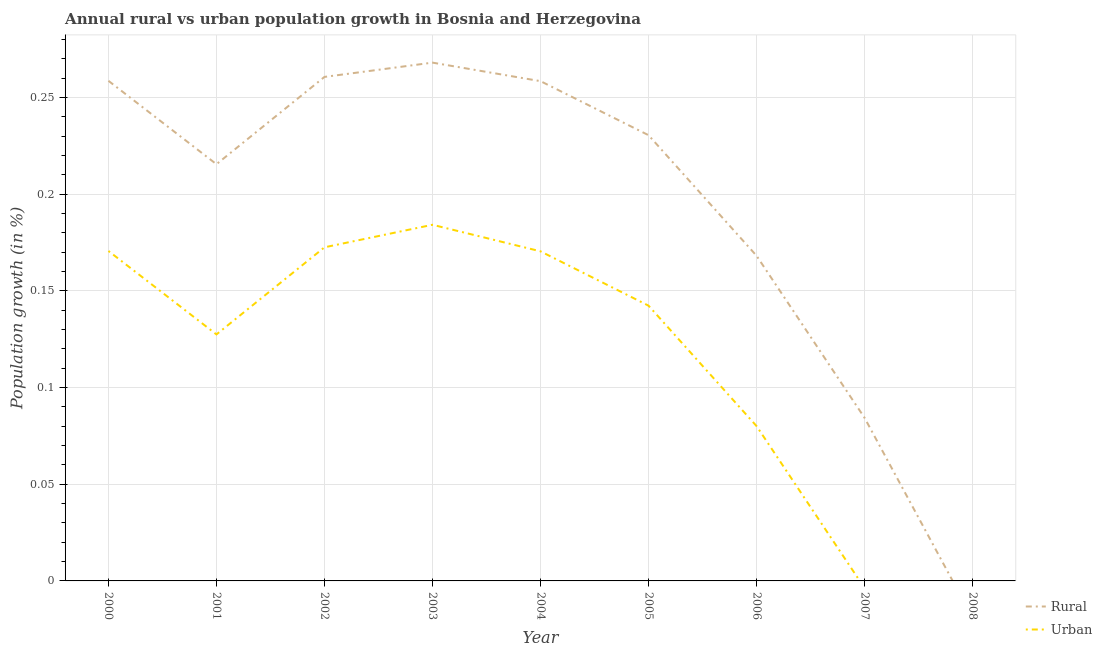How many different coloured lines are there?
Offer a very short reply. 2. Is the number of lines equal to the number of legend labels?
Give a very brief answer. No. What is the rural population growth in 2002?
Offer a very short reply. 0.26. Across all years, what is the maximum rural population growth?
Keep it short and to the point. 0.27. Across all years, what is the minimum urban population growth?
Give a very brief answer. 0. In which year was the urban population growth maximum?
Offer a terse response. 2003. What is the total rural population growth in the graph?
Offer a terse response. 1.74. What is the difference between the urban population growth in 2003 and that in 2006?
Give a very brief answer. 0.1. What is the difference between the rural population growth in 2006 and the urban population growth in 2002?
Your response must be concise. -0. What is the average rural population growth per year?
Give a very brief answer. 0.19. In the year 2004, what is the difference between the rural population growth and urban population growth?
Provide a succinct answer. 0.09. What is the ratio of the urban population growth in 2002 to that in 2003?
Keep it short and to the point. 0.94. Is the urban population growth in 2002 less than that in 2006?
Make the answer very short. No. What is the difference between the highest and the second highest rural population growth?
Offer a very short reply. 0.01. What is the difference between the highest and the lowest rural population growth?
Provide a succinct answer. 0.27. Is the rural population growth strictly greater than the urban population growth over the years?
Your answer should be very brief. No. Is the rural population growth strictly less than the urban population growth over the years?
Your response must be concise. No. Where does the legend appear in the graph?
Keep it short and to the point. Bottom right. What is the title of the graph?
Offer a very short reply. Annual rural vs urban population growth in Bosnia and Herzegovina. Does "Researchers" appear as one of the legend labels in the graph?
Keep it short and to the point. No. What is the label or title of the X-axis?
Provide a short and direct response. Year. What is the label or title of the Y-axis?
Offer a very short reply. Population growth (in %). What is the Population growth (in %) in Rural in 2000?
Your response must be concise. 0.26. What is the Population growth (in %) of Urban  in 2000?
Provide a succinct answer. 0.17. What is the Population growth (in %) in Rural in 2001?
Ensure brevity in your answer.  0.22. What is the Population growth (in %) in Urban  in 2001?
Ensure brevity in your answer.  0.13. What is the Population growth (in %) of Rural in 2002?
Make the answer very short. 0.26. What is the Population growth (in %) in Urban  in 2002?
Your answer should be very brief. 0.17. What is the Population growth (in %) of Rural in 2003?
Keep it short and to the point. 0.27. What is the Population growth (in %) of Urban  in 2003?
Keep it short and to the point. 0.18. What is the Population growth (in %) of Rural in 2004?
Provide a succinct answer. 0.26. What is the Population growth (in %) in Urban  in 2004?
Provide a short and direct response. 0.17. What is the Population growth (in %) of Rural in 2005?
Keep it short and to the point. 0.23. What is the Population growth (in %) of Urban  in 2005?
Give a very brief answer. 0.14. What is the Population growth (in %) of Rural in 2006?
Ensure brevity in your answer.  0.17. What is the Population growth (in %) of Urban  in 2006?
Ensure brevity in your answer.  0.08. What is the Population growth (in %) of Rural in 2007?
Make the answer very short. 0.08. What is the Population growth (in %) in Urban  in 2007?
Offer a terse response. 0. What is the Population growth (in %) in Rural in 2008?
Your answer should be compact. 0. What is the Population growth (in %) of Urban  in 2008?
Give a very brief answer. 0. Across all years, what is the maximum Population growth (in %) in Rural?
Your response must be concise. 0.27. Across all years, what is the maximum Population growth (in %) of Urban ?
Ensure brevity in your answer.  0.18. Across all years, what is the minimum Population growth (in %) in Rural?
Keep it short and to the point. 0. Across all years, what is the minimum Population growth (in %) in Urban ?
Your answer should be compact. 0. What is the total Population growth (in %) of Rural in the graph?
Your response must be concise. 1.74. What is the total Population growth (in %) in Urban  in the graph?
Provide a short and direct response. 1.05. What is the difference between the Population growth (in %) of Rural in 2000 and that in 2001?
Give a very brief answer. 0.04. What is the difference between the Population growth (in %) in Urban  in 2000 and that in 2001?
Offer a terse response. 0.04. What is the difference between the Population growth (in %) in Rural in 2000 and that in 2002?
Provide a short and direct response. -0. What is the difference between the Population growth (in %) in Urban  in 2000 and that in 2002?
Provide a short and direct response. -0. What is the difference between the Population growth (in %) in Rural in 2000 and that in 2003?
Offer a terse response. -0.01. What is the difference between the Population growth (in %) of Urban  in 2000 and that in 2003?
Provide a succinct answer. -0.01. What is the difference between the Population growth (in %) of Rural in 2000 and that in 2005?
Offer a very short reply. 0.03. What is the difference between the Population growth (in %) of Urban  in 2000 and that in 2005?
Your answer should be very brief. 0.03. What is the difference between the Population growth (in %) in Rural in 2000 and that in 2006?
Provide a short and direct response. 0.09. What is the difference between the Population growth (in %) of Urban  in 2000 and that in 2006?
Your response must be concise. 0.09. What is the difference between the Population growth (in %) of Rural in 2000 and that in 2007?
Offer a terse response. 0.17. What is the difference between the Population growth (in %) in Rural in 2001 and that in 2002?
Give a very brief answer. -0.05. What is the difference between the Population growth (in %) of Urban  in 2001 and that in 2002?
Your answer should be compact. -0.05. What is the difference between the Population growth (in %) of Rural in 2001 and that in 2003?
Provide a succinct answer. -0.05. What is the difference between the Population growth (in %) in Urban  in 2001 and that in 2003?
Make the answer very short. -0.06. What is the difference between the Population growth (in %) in Rural in 2001 and that in 2004?
Make the answer very short. -0.04. What is the difference between the Population growth (in %) in Urban  in 2001 and that in 2004?
Give a very brief answer. -0.04. What is the difference between the Population growth (in %) of Rural in 2001 and that in 2005?
Give a very brief answer. -0.01. What is the difference between the Population growth (in %) of Urban  in 2001 and that in 2005?
Make the answer very short. -0.01. What is the difference between the Population growth (in %) of Rural in 2001 and that in 2006?
Offer a terse response. 0.05. What is the difference between the Population growth (in %) in Urban  in 2001 and that in 2006?
Your answer should be compact. 0.05. What is the difference between the Population growth (in %) in Rural in 2001 and that in 2007?
Your answer should be very brief. 0.13. What is the difference between the Population growth (in %) of Rural in 2002 and that in 2003?
Give a very brief answer. -0.01. What is the difference between the Population growth (in %) in Urban  in 2002 and that in 2003?
Your answer should be compact. -0.01. What is the difference between the Population growth (in %) in Rural in 2002 and that in 2004?
Make the answer very short. 0. What is the difference between the Population growth (in %) in Urban  in 2002 and that in 2004?
Provide a short and direct response. 0. What is the difference between the Population growth (in %) of Rural in 2002 and that in 2005?
Offer a terse response. 0.03. What is the difference between the Population growth (in %) of Urban  in 2002 and that in 2005?
Your answer should be compact. 0.03. What is the difference between the Population growth (in %) of Rural in 2002 and that in 2006?
Your answer should be very brief. 0.09. What is the difference between the Population growth (in %) of Urban  in 2002 and that in 2006?
Your answer should be very brief. 0.09. What is the difference between the Population growth (in %) in Rural in 2002 and that in 2007?
Provide a succinct answer. 0.18. What is the difference between the Population growth (in %) of Rural in 2003 and that in 2004?
Give a very brief answer. 0.01. What is the difference between the Population growth (in %) in Urban  in 2003 and that in 2004?
Your answer should be very brief. 0.01. What is the difference between the Population growth (in %) of Rural in 2003 and that in 2005?
Your answer should be compact. 0.04. What is the difference between the Population growth (in %) in Urban  in 2003 and that in 2005?
Offer a very short reply. 0.04. What is the difference between the Population growth (in %) in Rural in 2003 and that in 2006?
Your answer should be very brief. 0.1. What is the difference between the Population growth (in %) in Urban  in 2003 and that in 2006?
Offer a very short reply. 0.1. What is the difference between the Population growth (in %) of Rural in 2003 and that in 2007?
Offer a very short reply. 0.18. What is the difference between the Population growth (in %) in Rural in 2004 and that in 2005?
Make the answer very short. 0.03. What is the difference between the Population growth (in %) in Urban  in 2004 and that in 2005?
Provide a short and direct response. 0.03. What is the difference between the Population growth (in %) of Rural in 2004 and that in 2006?
Provide a short and direct response. 0.09. What is the difference between the Population growth (in %) of Urban  in 2004 and that in 2006?
Offer a very short reply. 0.09. What is the difference between the Population growth (in %) in Rural in 2004 and that in 2007?
Keep it short and to the point. 0.17. What is the difference between the Population growth (in %) in Rural in 2005 and that in 2006?
Provide a succinct answer. 0.06. What is the difference between the Population growth (in %) in Urban  in 2005 and that in 2006?
Your response must be concise. 0.06. What is the difference between the Population growth (in %) in Rural in 2005 and that in 2007?
Provide a succinct answer. 0.15. What is the difference between the Population growth (in %) of Rural in 2006 and that in 2007?
Make the answer very short. 0.08. What is the difference between the Population growth (in %) of Rural in 2000 and the Population growth (in %) of Urban  in 2001?
Give a very brief answer. 0.13. What is the difference between the Population growth (in %) of Rural in 2000 and the Population growth (in %) of Urban  in 2002?
Provide a short and direct response. 0.09. What is the difference between the Population growth (in %) of Rural in 2000 and the Population growth (in %) of Urban  in 2003?
Offer a very short reply. 0.07. What is the difference between the Population growth (in %) of Rural in 2000 and the Population growth (in %) of Urban  in 2004?
Offer a very short reply. 0.09. What is the difference between the Population growth (in %) of Rural in 2000 and the Population growth (in %) of Urban  in 2005?
Your answer should be very brief. 0.12. What is the difference between the Population growth (in %) in Rural in 2000 and the Population growth (in %) in Urban  in 2006?
Keep it short and to the point. 0.18. What is the difference between the Population growth (in %) in Rural in 2001 and the Population growth (in %) in Urban  in 2002?
Make the answer very short. 0.04. What is the difference between the Population growth (in %) in Rural in 2001 and the Population growth (in %) in Urban  in 2003?
Your response must be concise. 0.03. What is the difference between the Population growth (in %) of Rural in 2001 and the Population growth (in %) of Urban  in 2004?
Provide a succinct answer. 0.05. What is the difference between the Population growth (in %) of Rural in 2001 and the Population growth (in %) of Urban  in 2005?
Offer a terse response. 0.07. What is the difference between the Population growth (in %) in Rural in 2001 and the Population growth (in %) in Urban  in 2006?
Make the answer very short. 0.14. What is the difference between the Population growth (in %) of Rural in 2002 and the Population growth (in %) of Urban  in 2003?
Your response must be concise. 0.08. What is the difference between the Population growth (in %) of Rural in 2002 and the Population growth (in %) of Urban  in 2004?
Give a very brief answer. 0.09. What is the difference between the Population growth (in %) in Rural in 2002 and the Population growth (in %) in Urban  in 2005?
Offer a very short reply. 0.12. What is the difference between the Population growth (in %) in Rural in 2002 and the Population growth (in %) in Urban  in 2006?
Your answer should be very brief. 0.18. What is the difference between the Population growth (in %) in Rural in 2003 and the Population growth (in %) in Urban  in 2004?
Your answer should be compact. 0.1. What is the difference between the Population growth (in %) in Rural in 2003 and the Population growth (in %) in Urban  in 2005?
Your answer should be very brief. 0.13. What is the difference between the Population growth (in %) of Rural in 2003 and the Population growth (in %) of Urban  in 2006?
Keep it short and to the point. 0.19. What is the difference between the Population growth (in %) of Rural in 2004 and the Population growth (in %) of Urban  in 2005?
Provide a short and direct response. 0.12. What is the difference between the Population growth (in %) of Rural in 2004 and the Population growth (in %) of Urban  in 2006?
Offer a very short reply. 0.18. What is the difference between the Population growth (in %) of Rural in 2005 and the Population growth (in %) of Urban  in 2006?
Keep it short and to the point. 0.15. What is the average Population growth (in %) of Rural per year?
Give a very brief answer. 0.19. What is the average Population growth (in %) of Urban  per year?
Your response must be concise. 0.12. In the year 2000, what is the difference between the Population growth (in %) in Rural and Population growth (in %) in Urban ?
Offer a terse response. 0.09. In the year 2001, what is the difference between the Population growth (in %) of Rural and Population growth (in %) of Urban ?
Your answer should be compact. 0.09. In the year 2002, what is the difference between the Population growth (in %) in Rural and Population growth (in %) in Urban ?
Offer a very short reply. 0.09. In the year 2003, what is the difference between the Population growth (in %) of Rural and Population growth (in %) of Urban ?
Offer a very short reply. 0.08. In the year 2004, what is the difference between the Population growth (in %) of Rural and Population growth (in %) of Urban ?
Provide a succinct answer. 0.09. In the year 2005, what is the difference between the Population growth (in %) of Rural and Population growth (in %) of Urban ?
Ensure brevity in your answer.  0.09. In the year 2006, what is the difference between the Population growth (in %) in Rural and Population growth (in %) in Urban ?
Your response must be concise. 0.09. What is the ratio of the Population growth (in %) in Rural in 2000 to that in 2001?
Your answer should be compact. 1.2. What is the ratio of the Population growth (in %) in Urban  in 2000 to that in 2001?
Provide a succinct answer. 1.34. What is the ratio of the Population growth (in %) of Urban  in 2000 to that in 2002?
Ensure brevity in your answer.  0.99. What is the ratio of the Population growth (in %) of Rural in 2000 to that in 2003?
Your answer should be very brief. 0.96. What is the ratio of the Population growth (in %) in Urban  in 2000 to that in 2003?
Ensure brevity in your answer.  0.93. What is the ratio of the Population growth (in %) of Urban  in 2000 to that in 2004?
Your answer should be compact. 1. What is the ratio of the Population growth (in %) in Rural in 2000 to that in 2005?
Give a very brief answer. 1.12. What is the ratio of the Population growth (in %) in Urban  in 2000 to that in 2005?
Provide a succinct answer. 1.2. What is the ratio of the Population growth (in %) of Rural in 2000 to that in 2006?
Make the answer very short. 1.54. What is the ratio of the Population growth (in %) in Urban  in 2000 to that in 2006?
Give a very brief answer. 2.13. What is the ratio of the Population growth (in %) in Rural in 2000 to that in 2007?
Offer a very short reply. 3.07. What is the ratio of the Population growth (in %) of Rural in 2001 to that in 2002?
Offer a very short reply. 0.83. What is the ratio of the Population growth (in %) in Urban  in 2001 to that in 2002?
Give a very brief answer. 0.74. What is the ratio of the Population growth (in %) in Rural in 2001 to that in 2003?
Keep it short and to the point. 0.8. What is the ratio of the Population growth (in %) in Urban  in 2001 to that in 2003?
Make the answer very short. 0.69. What is the ratio of the Population growth (in %) in Rural in 2001 to that in 2004?
Offer a very short reply. 0.83. What is the ratio of the Population growth (in %) of Urban  in 2001 to that in 2004?
Provide a short and direct response. 0.75. What is the ratio of the Population growth (in %) of Rural in 2001 to that in 2005?
Make the answer very short. 0.93. What is the ratio of the Population growth (in %) in Urban  in 2001 to that in 2005?
Your response must be concise. 0.9. What is the ratio of the Population growth (in %) of Rural in 2001 to that in 2006?
Your answer should be compact. 1.28. What is the ratio of the Population growth (in %) of Urban  in 2001 to that in 2006?
Your answer should be compact. 1.59. What is the ratio of the Population growth (in %) of Rural in 2001 to that in 2007?
Make the answer very short. 2.56. What is the ratio of the Population growth (in %) in Rural in 2002 to that in 2003?
Offer a very short reply. 0.97. What is the ratio of the Population growth (in %) in Urban  in 2002 to that in 2003?
Offer a very short reply. 0.94. What is the ratio of the Population growth (in %) in Rural in 2002 to that in 2004?
Your answer should be very brief. 1.01. What is the ratio of the Population growth (in %) of Urban  in 2002 to that in 2004?
Make the answer very short. 1.01. What is the ratio of the Population growth (in %) in Rural in 2002 to that in 2005?
Offer a terse response. 1.13. What is the ratio of the Population growth (in %) of Urban  in 2002 to that in 2005?
Keep it short and to the point. 1.21. What is the ratio of the Population growth (in %) of Rural in 2002 to that in 2006?
Offer a very short reply. 1.55. What is the ratio of the Population growth (in %) of Urban  in 2002 to that in 2006?
Your response must be concise. 2.15. What is the ratio of the Population growth (in %) of Rural in 2002 to that in 2007?
Keep it short and to the point. 3.09. What is the ratio of the Population growth (in %) of Urban  in 2003 to that in 2004?
Provide a short and direct response. 1.08. What is the ratio of the Population growth (in %) of Rural in 2003 to that in 2005?
Provide a succinct answer. 1.16. What is the ratio of the Population growth (in %) of Urban  in 2003 to that in 2005?
Offer a very short reply. 1.29. What is the ratio of the Population growth (in %) of Rural in 2003 to that in 2006?
Your answer should be very brief. 1.59. What is the ratio of the Population growth (in %) of Urban  in 2003 to that in 2006?
Your answer should be very brief. 2.3. What is the ratio of the Population growth (in %) of Rural in 2003 to that in 2007?
Ensure brevity in your answer.  3.18. What is the ratio of the Population growth (in %) in Rural in 2004 to that in 2005?
Your response must be concise. 1.12. What is the ratio of the Population growth (in %) in Urban  in 2004 to that in 2005?
Offer a very short reply. 1.2. What is the ratio of the Population growth (in %) in Rural in 2004 to that in 2006?
Keep it short and to the point. 1.54. What is the ratio of the Population growth (in %) in Urban  in 2004 to that in 2006?
Your answer should be compact. 2.13. What is the ratio of the Population growth (in %) of Rural in 2004 to that in 2007?
Offer a terse response. 3.06. What is the ratio of the Population growth (in %) in Rural in 2005 to that in 2006?
Ensure brevity in your answer.  1.37. What is the ratio of the Population growth (in %) of Urban  in 2005 to that in 2006?
Provide a succinct answer. 1.78. What is the ratio of the Population growth (in %) of Rural in 2005 to that in 2007?
Provide a succinct answer. 2.73. What is the ratio of the Population growth (in %) of Rural in 2006 to that in 2007?
Offer a terse response. 1.99. What is the difference between the highest and the second highest Population growth (in %) of Rural?
Provide a succinct answer. 0.01. What is the difference between the highest and the second highest Population growth (in %) in Urban ?
Keep it short and to the point. 0.01. What is the difference between the highest and the lowest Population growth (in %) of Rural?
Keep it short and to the point. 0.27. What is the difference between the highest and the lowest Population growth (in %) of Urban ?
Keep it short and to the point. 0.18. 